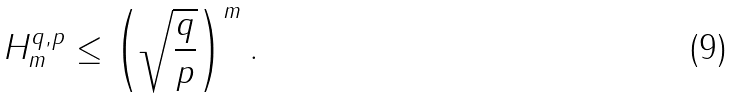<formula> <loc_0><loc_0><loc_500><loc_500>H ^ { q , p } _ { m } \leq \left ( \sqrt { \frac { q } { p } } \right ) ^ { m } .</formula> 